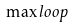<formula> <loc_0><loc_0><loc_500><loc_500>\max l o o p</formula> 